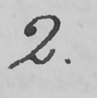Can you read and transcribe this handwriting? 2 . 